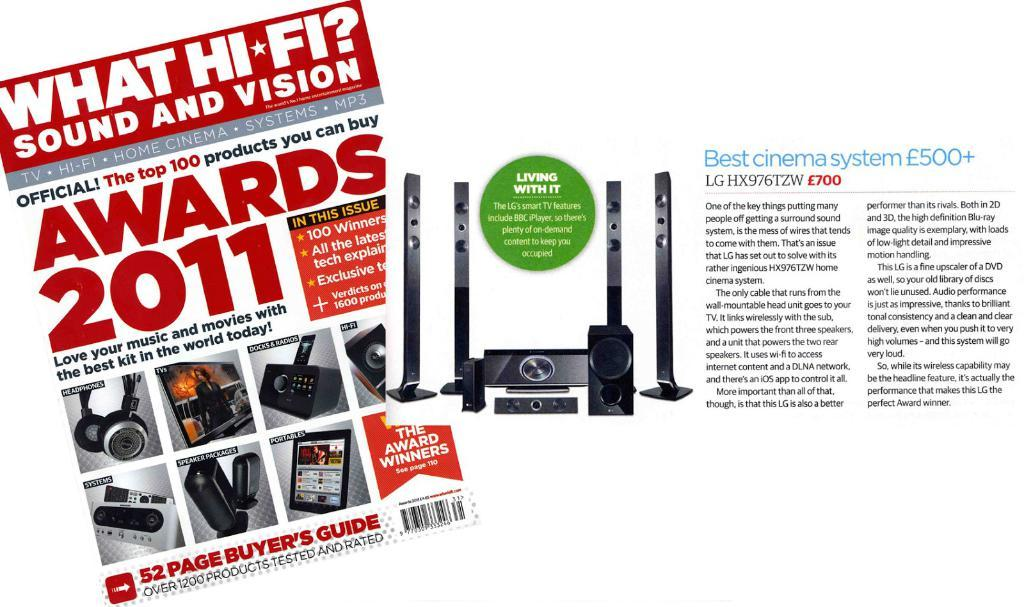Provide a one-sentence caption for the provided image. Magazine for "What Hi-Fi" advertising a set of speakers. 